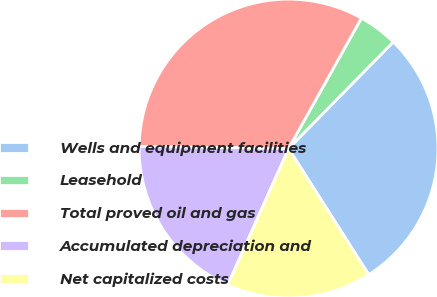Convert chart to OTSL. <chart><loc_0><loc_0><loc_500><loc_500><pie_chart><fcel>Wells and equipment facilities<fcel>Leasehold<fcel>Total proved oil and gas<fcel>Accumulated depreciation and<fcel>Net capitalized costs<nl><fcel>28.63%<fcel>4.25%<fcel>32.88%<fcel>18.55%<fcel>15.69%<nl></chart> 